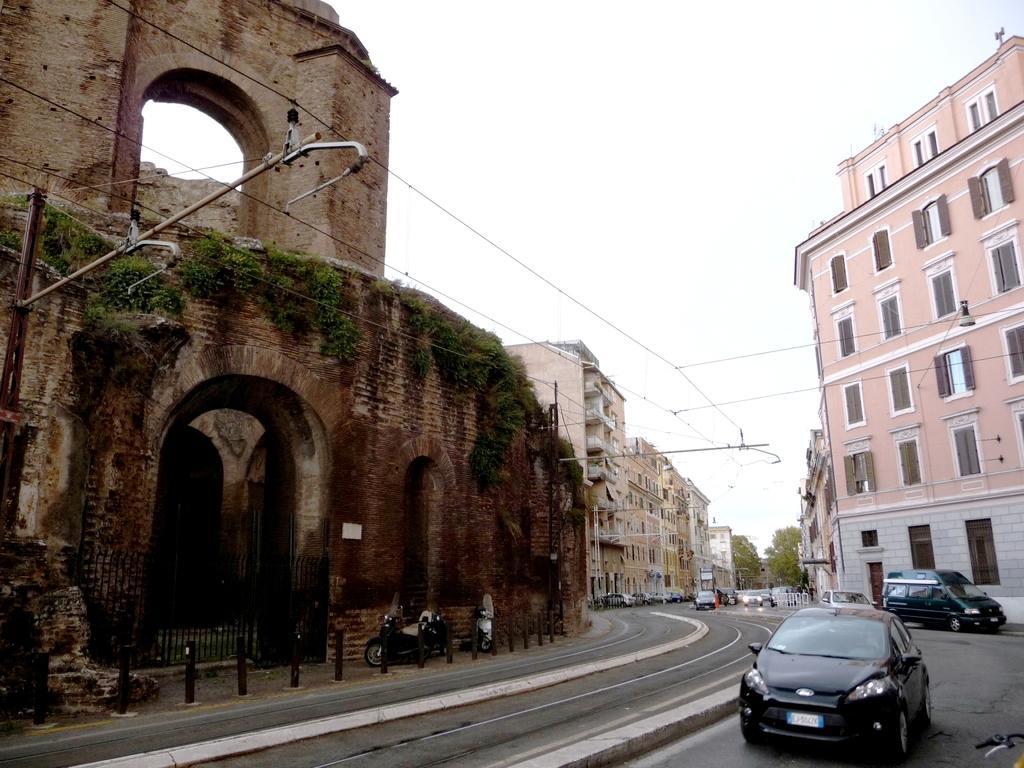How would you summarize this image in a sentence or two? In this image I can see some vehicles on the road. In the background, I can see the buildings, trees and the sky. 